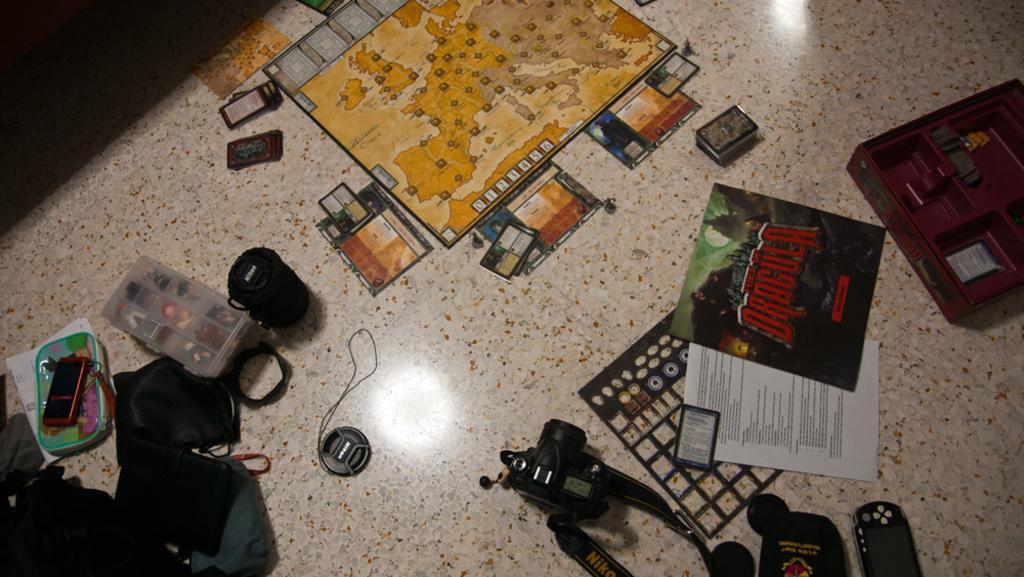Please provide a concise description of this image. In the picture i can see camera, camera lens, remote, mobile phone, box, bags, papers and some other items which are on floor. 